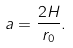<formula> <loc_0><loc_0><loc_500><loc_500>a = \frac { 2 H } { r _ { 0 } } .</formula> 